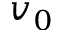Convert formula to latex. <formula><loc_0><loc_0><loc_500><loc_500>v _ { 0 }</formula> 